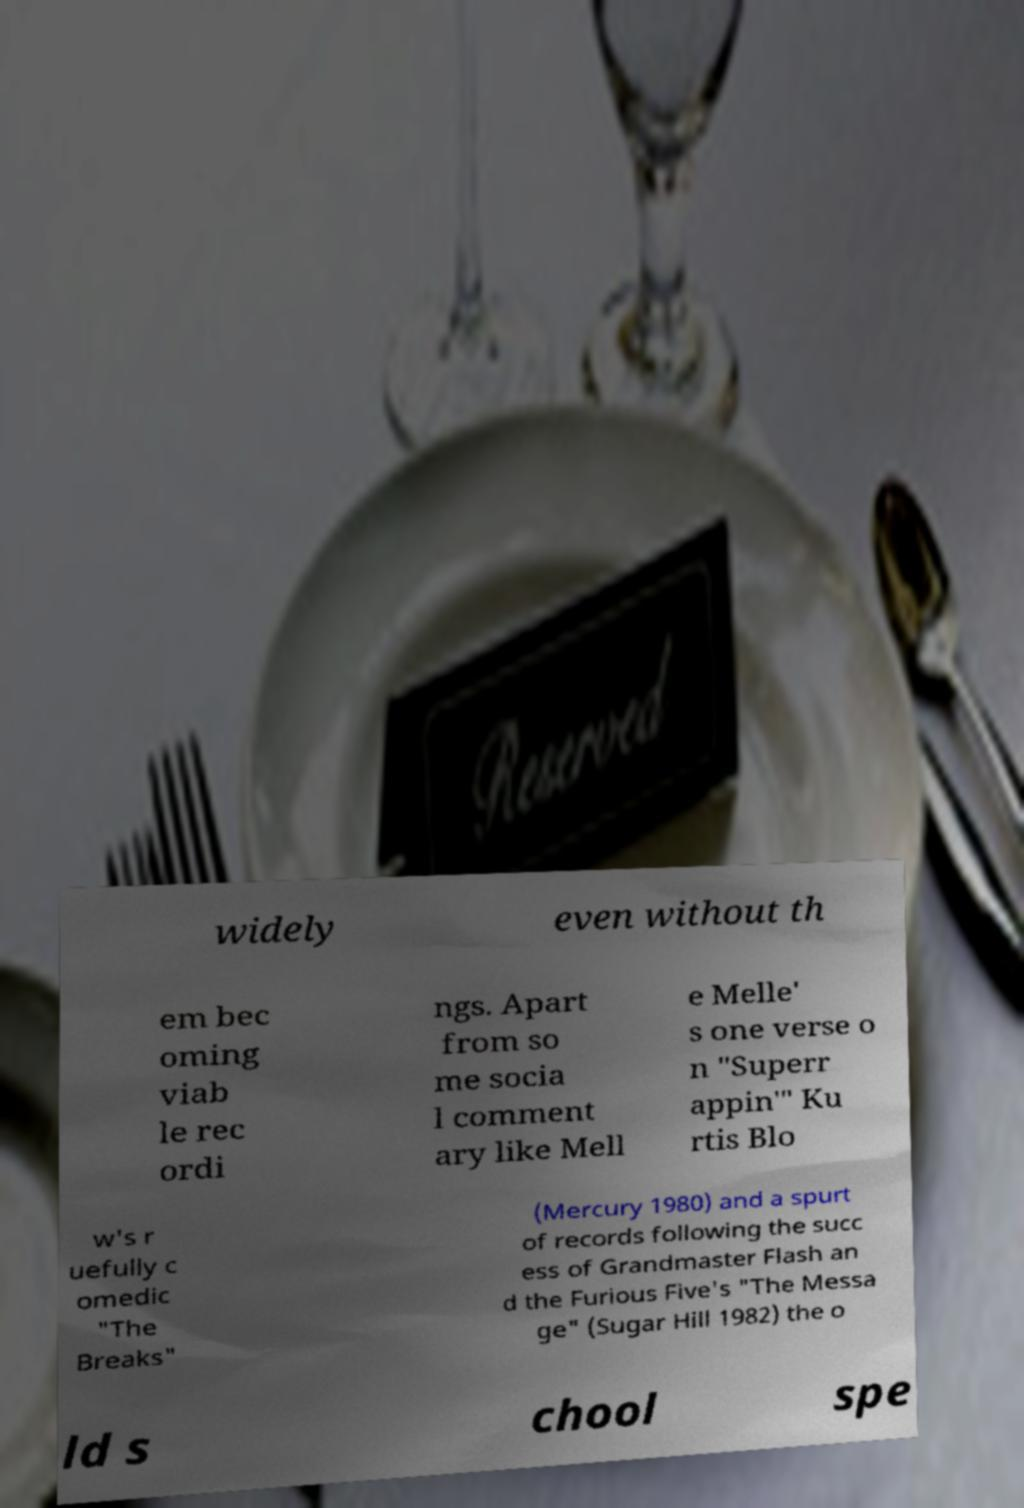There's text embedded in this image that I need extracted. Can you transcribe it verbatim? widely even without th em bec oming viab le rec ordi ngs. Apart from so me socia l comment ary like Mell e Melle' s one verse o n "Superr appin'" Ku rtis Blo w's r uefully c omedic "The Breaks" (Mercury 1980) and a spurt of records following the succ ess of Grandmaster Flash an d the Furious Five's "The Messa ge" (Sugar Hill 1982) the o ld s chool spe 